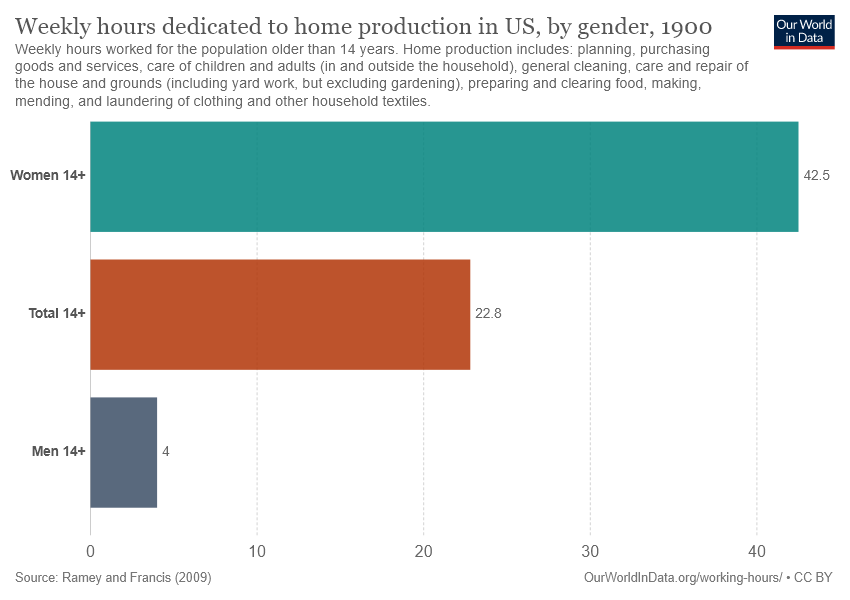Draw attention to some important aspects in this diagram. The bar color representing women is blue. In the US, the weekly hours devoted to home production by women and men differ. 